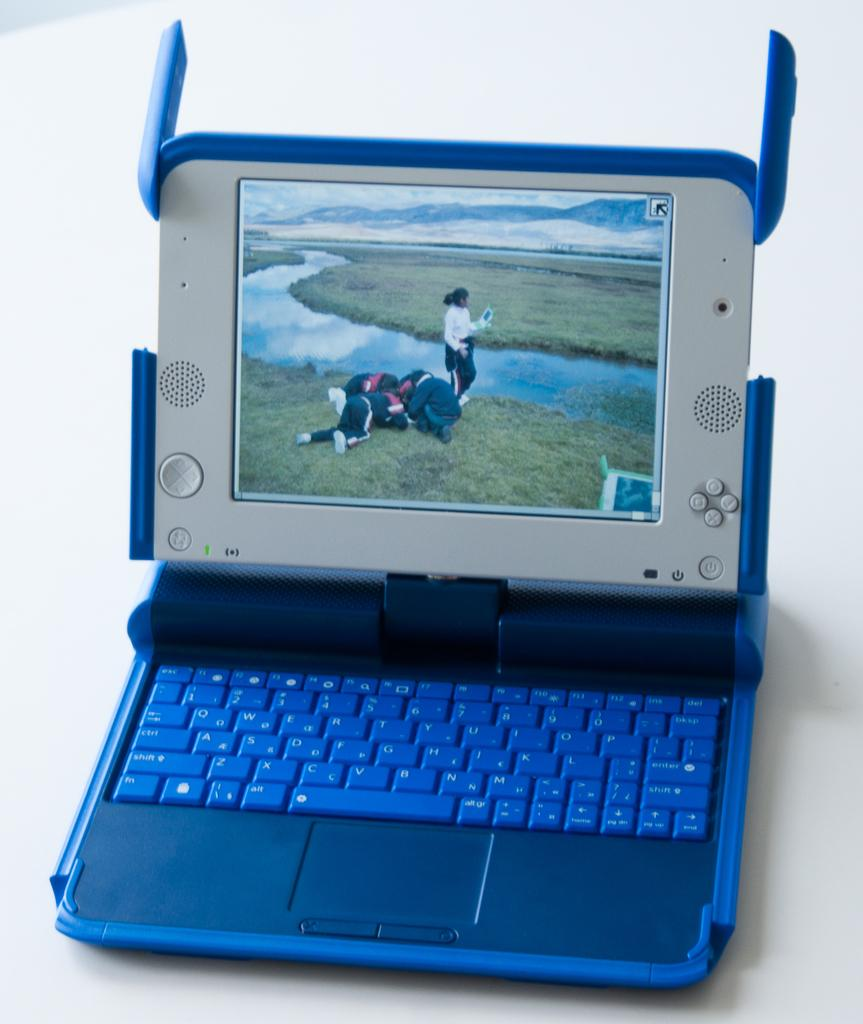What electronic device is visible in the image? There is a laptop in the image. Where is the laptop placed? The laptop is on a platform. How many legs does the laptop have in the image? Laptops do not have legs; they have a base that rests on a surface. In this case, the laptop is on a platform. 